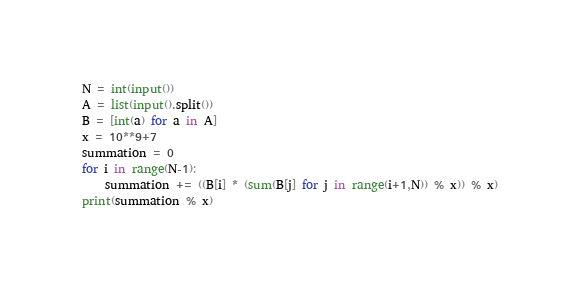Convert code to text. <code><loc_0><loc_0><loc_500><loc_500><_Python_>N = int(input())
A = list(input().split())
B = [int(a) for a in A]
x = 10**9+7
summation = 0
for i in range(N-1):
    summation += ((B[i] * (sum(B[j] for j in range(i+1,N)) % x)) % x)
print(summation % x)
</code> 